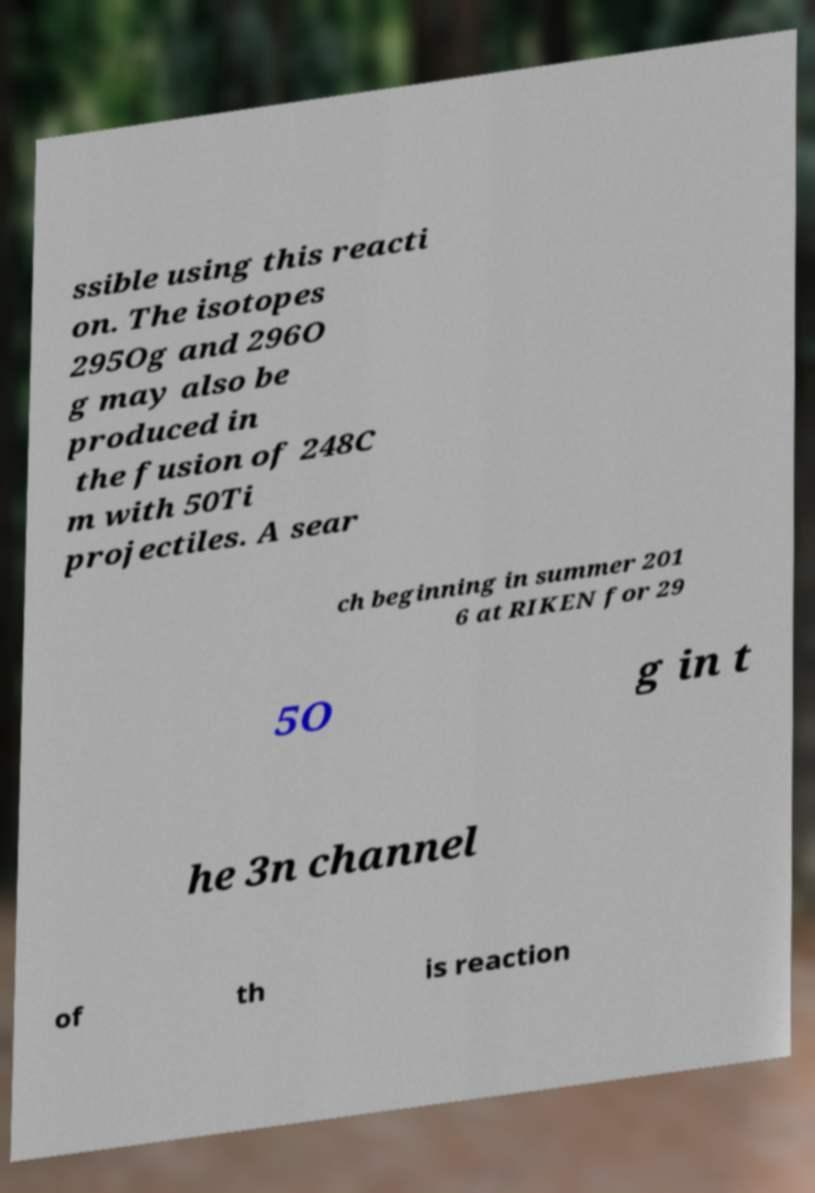Please identify and transcribe the text found in this image. ssible using this reacti on. The isotopes 295Og and 296O g may also be produced in the fusion of 248C m with 50Ti projectiles. A sear ch beginning in summer 201 6 at RIKEN for 29 5O g in t he 3n channel of th is reaction 